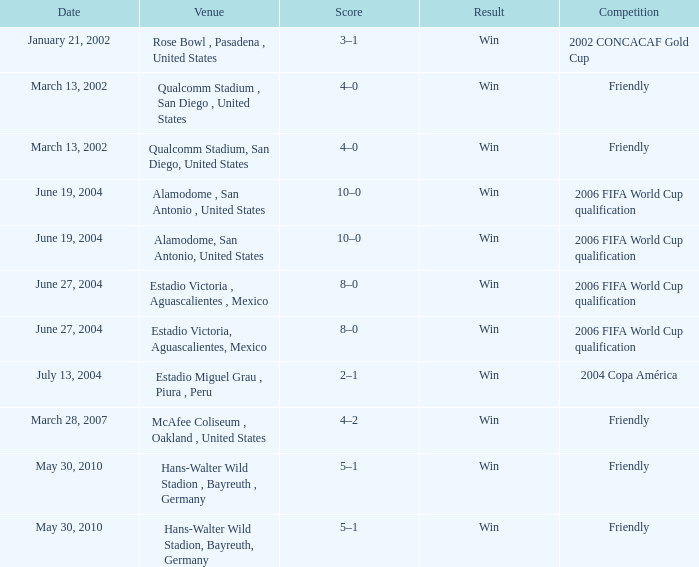When is the alamodome in san antonio, us being used as the venue? June 19, 2004, June 19, 2004. 